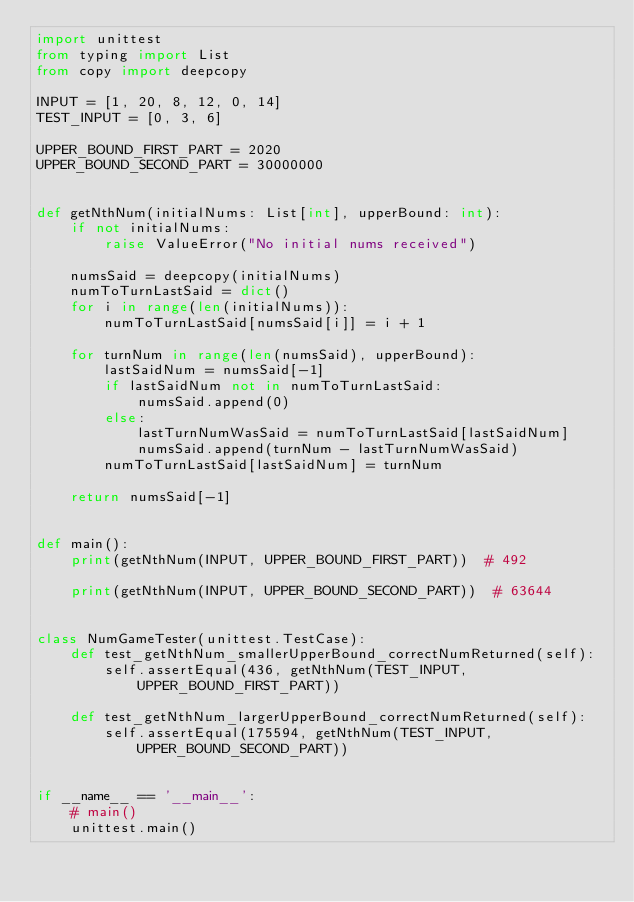<code> <loc_0><loc_0><loc_500><loc_500><_Python_>import unittest
from typing import List
from copy import deepcopy

INPUT = [1, 20, 8, 12, 0, 14]
TEST_INPUT = [0, 3, 6]

UPPER_BOUND_FIRST_PART = 2020
UPPER_BOUND_SECOND_PART = 30000000


def getNthNum(initialNums: List[int], upperBound: int):
    if not initialNums:
        raise ValueError("No initial nums received")

    numsSaid = deepcopy(initialNums)
    numToTurnLastSaid = dict()
    for i in range(len(initialNums)):
        numToTurnLastSaid[numsSaid[i]] = i + 1

    for turnNum in range(len(numsSaid), upperBound):
        lastSaidNum = numsSaid[-1]
        if lastSaidNum not in numToTurnLastSaid:
            numsSaid.append(0)
        else:
            lastTurnNumWasSaid = numToTurnLastSaid[lastSaidNum]
            numsSaid.append(turnNum - lastTurnNumWasSaid)
        numToTurnLastSaid[lastSaidNum] = turnNum

    return numsSaid[-1]


def main():
    print(getNthNum(INPUT, UPPER_BOUND_FIRST_PART))  # 492

    print(getNthNum(INPUT, UPPER_BOUND_SECOND_PART))  # 63644


class NumGameTester(unittest.TestCase):
    def test_getNthNum_smallerUpperBound_correctNumReturned(self):
        self.assertEqual(436, getNthNum(TEST_INPUT, UPPER_BOUND_FIRST_PART))

    def test_getNthNum_largerUpperBound_correctNumReturned(self):
        self.assertEqual(175594, getNthNum(TEST_INPUT, UPPER_BOUND_SECOND_PART))


if __name__ == '__main__':
    # main()
    unittest.main()
</code> 